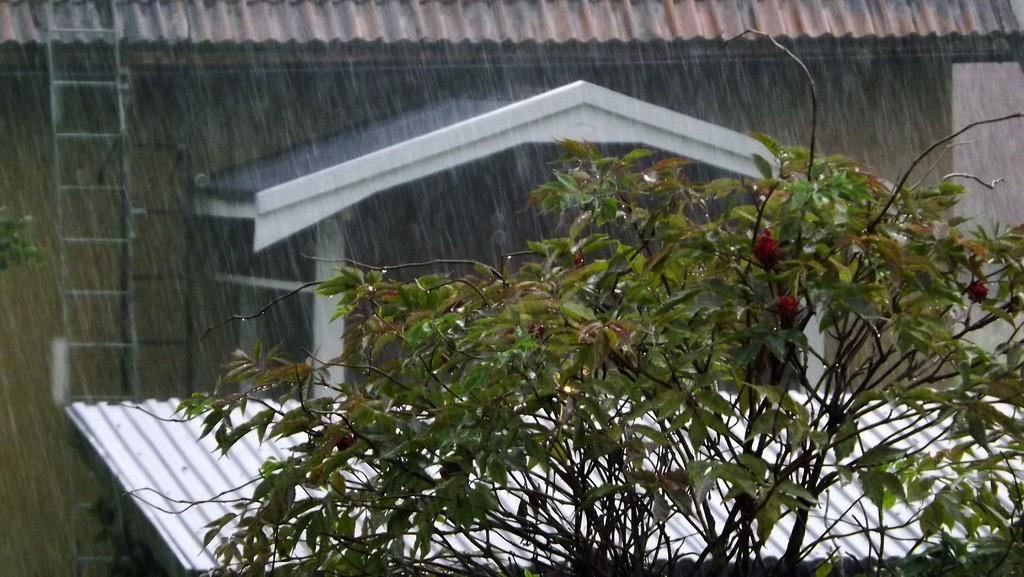In one or two sentences, can you explain what this image depicts? In this image we can see a plant with flowers, house, ladders, metal sheet and the rain is raining. 